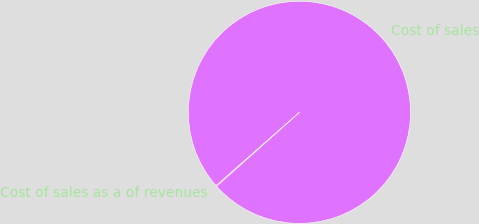Convert chart. <chart><loc_0><loc_0><loc_500><loc_500><pie_chart><fcel>Cost of sales<fcel>Cost of sales as a of revenues<nl><fcel>99.88%<fcel>0.12%<nl></chart> 